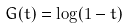Convert formula to latex. <formula><loc_0><loc_0><loc_500><loc_500>G ( t ) = \log ( 1 - t )</formula> 